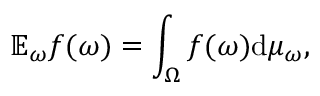Convert formula to latex. <formula><loc_0><loc_0><loc_500><loc_500>\mathbb { E } _ { \omega } f ( \omega ) = \int _ { \Omega } f ( \omega ) d \mu _ { \omega } ,</formula> 